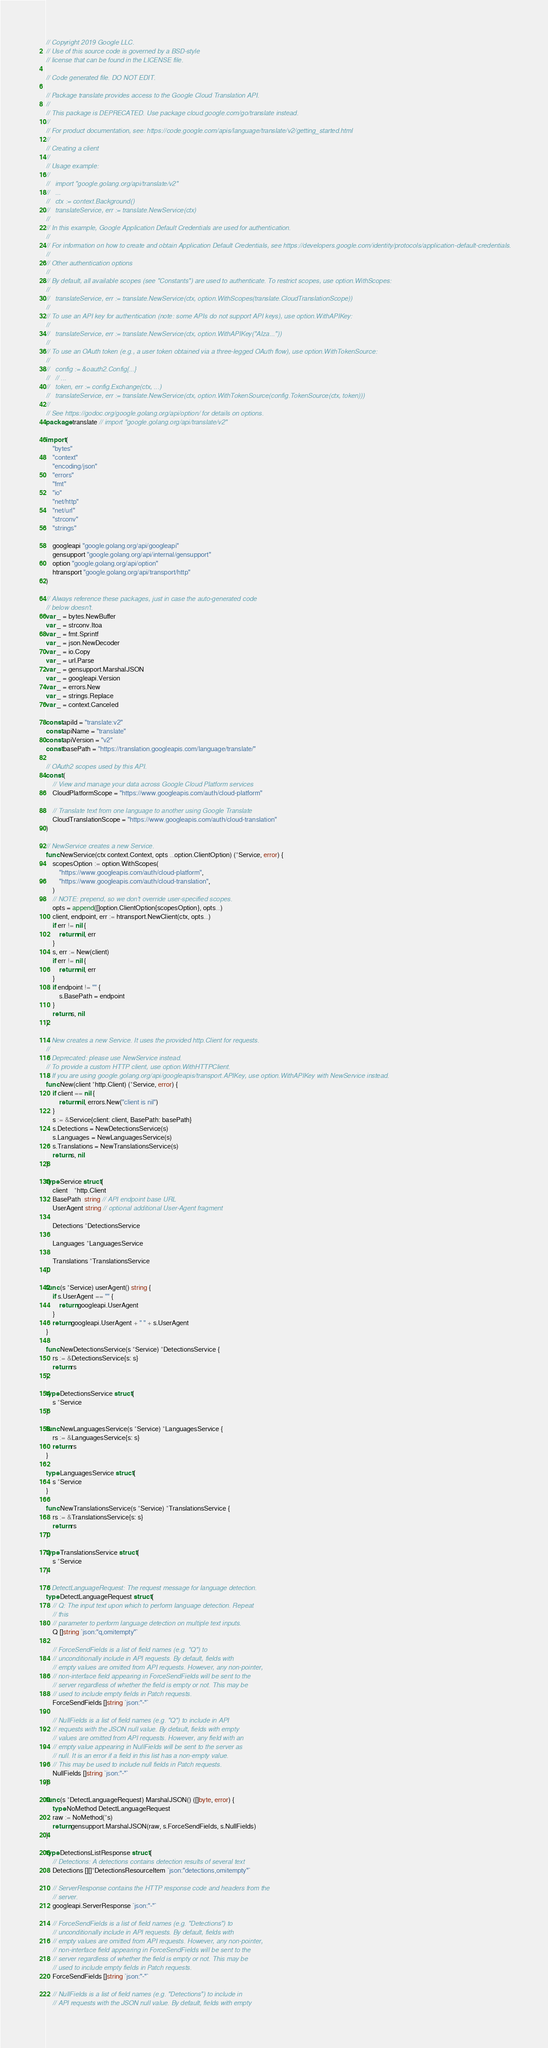<code> <loc_0><loc_0><loc_500><loc_500><_Go_>// Copyright 2019 Google LLC.
// Use of this source code is governed by a BSD-style
// license that can be found in the LICENSE file.

// Code generated file. DO NOT EDIT.

// Package translate provides access to the Google Cloud Translation API.
//
// This package is DEPRECATED. Use package cloud.google.com/go/translate instead.
//
// For product documentation, see: https://code.google.com/apis/language/translate/v2/getting_started.html
//
// Creating a client
//
// Usage example:
//
//   import "google.golang.org/api/translate/v2"
//   ...
//   ctx := context.Background()
//   translateService, err := translate.NewService(ctx)
//
// In this example, Google Application Default Credentials are used for authentication.
//
// For information on how to create and obtain Application Default Credentials, see https://developers.google.com/identity/protocols/application-default-credentials.
//
// Other authentication options
//
// By default, all available scopes (see "Constants") are used to authenticate. To restrict scopes, use option.WithScopes:
//
//   translateService, err := translate.NewService(ctx, option.WithScopes(translate.CloudTranslationScope))
//
// To use an API key for authentication (note: some APIs do not support API keys), use option.WithAPIKey:
//
//   translateService, err := translate.NewService(ctx, option.WithAPIKey("AIza..."))
//
// To use an OAuth token (e.g., a user token obtained via a three-legged OAuth flow), use option.WithTokenSource:
//
//   config := &oauth2.Config{...}
//   // ...
//   token, err := config.Exchange(ctx, ...)
//   translateService, err := translate.NewService(ctx, option.WithTokenSource(config.TokenSource(ctx, token)))
//
// See https://godoc.org/google.golang.org/api/option/ for details on options.
package translate // import "google.golang.org/api/translate/v2"

import (
	"bytes"
	"context"
	"encoding/json"
	"errors"
	"fmt"
	"io"
	"net/http"
	"net/url"
	"strconv"
	"strings"

	googleapi "google.golang.org/api/googleapi"
	gensupport "google.golang.org/api/internal/gensupport"
	option "google.golang.org/api/option"
	htransport "google.golang.org/api/transport/http"
)

// Always reference these packages, just in case the auto-generated code
// below doesn't.
var _ = bytes.NewBuffer
var _ = strconv.Itoa
var _ = fmt.Sprintf
var _ = json.NewDecoder
var _ = io.Copy
var _ = url.Parse
var _ = gensupport.MarshalJSON
var _ = googleapi.Version
var _ = errors.New
var _ = strings.Replace
var _ = context.Canceled

const apiId = "translate:v2"
const apiName = "translate"
const apiVersion = "v2"
const basePath = "https://translation.googleapis.com/language/translate/"

// OAuth2 scopes used by this API.
const (
	// View and manage your data across Google Cloud Platform services
	CloudPlatformScope = "https://www.googleapis.com/auth/cloud-platform"

	// Translate text from one language to another using Google Translate
	CloudTranslationScope = "https://www.googleapis.com/auth/cloud-translation"
)

// NewService creates a new Service.
func NewService(ctx context.Context, opts ...option.ClientOption) (*Service, error) {
	scopesOption := option.WithScopes(
		"https://www.googleapis.com/auth/cloud-platform",
		"https://www.googleapis.com/auth/cloud-translation",
	)
	// NOTE: prepend, so we don't override user-specified scopes.
	opts = append([]option.ClientOption{scopesOption}, opts...)
	client, endpoint, err := htransport.NewClient(ctx, opts...)
	if err != nil {
		return nil, err
	}
	s, err := New(client)
	if err != nil {
		return nil, err
	}
	if endpoint != "" {
		s.BasePath = endpoint
	}
	return s, nil
}

// New creates a new Service. It uses the provided http.Client for requests.
//
// Deprecated: please use NewService instead.
// To provide a custom HTTP client, use option.WithHTTPClient.
// If you are using google.golang.org/api/googleapis/transport.APIKey, use option.WithAPIKey with NewService instead.
func New(client *http.Client) (*Service, error) {
	if client == nil {
		return nil, errors.New("client is nil")
	}
	s := &Service{client: client, BasePath: basePath}
	s.Detections = NewDetectionsService(s)
	s.Languages = NewLanguagesService(s)
	s.Translations = NewTranslationsService(s)
	return s, nil
}

type Service struct {
	client    *http.Client
	BasePath  string // API endpoint base URL
	UserAgent string // optional additional User-Agent fragment

	Detections *DetectionsService

	Languages *LanguagesService

	Translations *TranslationsService
}

func (s *Service) userAgent() string {
	if s.UserAgent == "" {
		return googleapi.UserAgent
	}
	return googleapi.UserAgent + " " + s.UserAgent
}

func NewDetectionsService(s *Service) *DetectionsService {
	rs := &DetectionsService{s: s}
	return rs
}

type DetectionsService struct {
	s *Service
}

func NewLanguagesService(s *Service) *LanguagesService {
	rs := &LanguagesService{s: s}
	return rs
}

type LanguagesService struct {
	s *Service
}

func NewTranslationsService(s *Service) *TranslationsService {
	rs := &TranslationsService{s: s}
	return rs
}

type TranslationsService struct {
	s *Service
}

// DetectLanguageRequest: The request message for language detection.
type DetectLanguageRequest struct {
	// Q: The input text upon which to perform language detection. Repeat
	// this
	// parameter to perform language detection on multiple text inputs.
	Q []string `json:"q,omitempty"`

	// ForceSendFields is a list of field names (e.g. "Q") to
	// unconditionally include in API requests. By default, fields with
	// empty values are omitted from API requests. However, any non-pointer,
	// non-interface field appearing in ForceSendFields will be sent to the
	// server regardless of whether the field is empty or not. This may be
	// used to include empty fields in Patch requests.
	ForceSendFields []string `json:"-"`

	// NullFields is a list of field names (e.g. "Q") to include in API
	// requests with the JSON null value. By default, fields with empty
	// values are omitted from API requests. However, any field with an
	// empty value appearing in NullFields will be sent to the server as
	// null. It is an error if a field in this list has a non-empty value.
	// This may be used to include null fields in Patch requests.
	NullFields []string `json:"-"`
}

func (s *DetectLanguageRequest) MarshalJSON() ([]byte, error) {
	type NoMethod DetectLanguageRequest
	raw := NoMethod(*s)
	return gensupport.MarshalJSON(raw, s.ForceSendFields, s.NullFields)
}

type DetectionsListResponse struct {
	// Detections: A detections contains detection results of several text
	Detections [][]*DetectionsResourceItem `json:"detections,omitempty"`

	// ServerResponse contains the HTTP response code and headers from the
	// server.
	googleapi.ServerResponse `json:"-"`

	// ForceSendFields is a list of field names (e.g. "Detections") to
	// unconditionally include in API requests. By default, fields with
	// empty values are omitted from API requests. However, any non-pointer,
	// non-interface field appearing in ForceSendFields will be sent to the
	// server regardless of whether the field is empty or not. This may be
	// used to include empty fields in Patch requests.
	ForceSendFields []string `json:"-"`

	// NullFields is a list of field names (e.g. "Detections") to include in
	// API requests with the JSON null value. By default, fields with empty</code> 